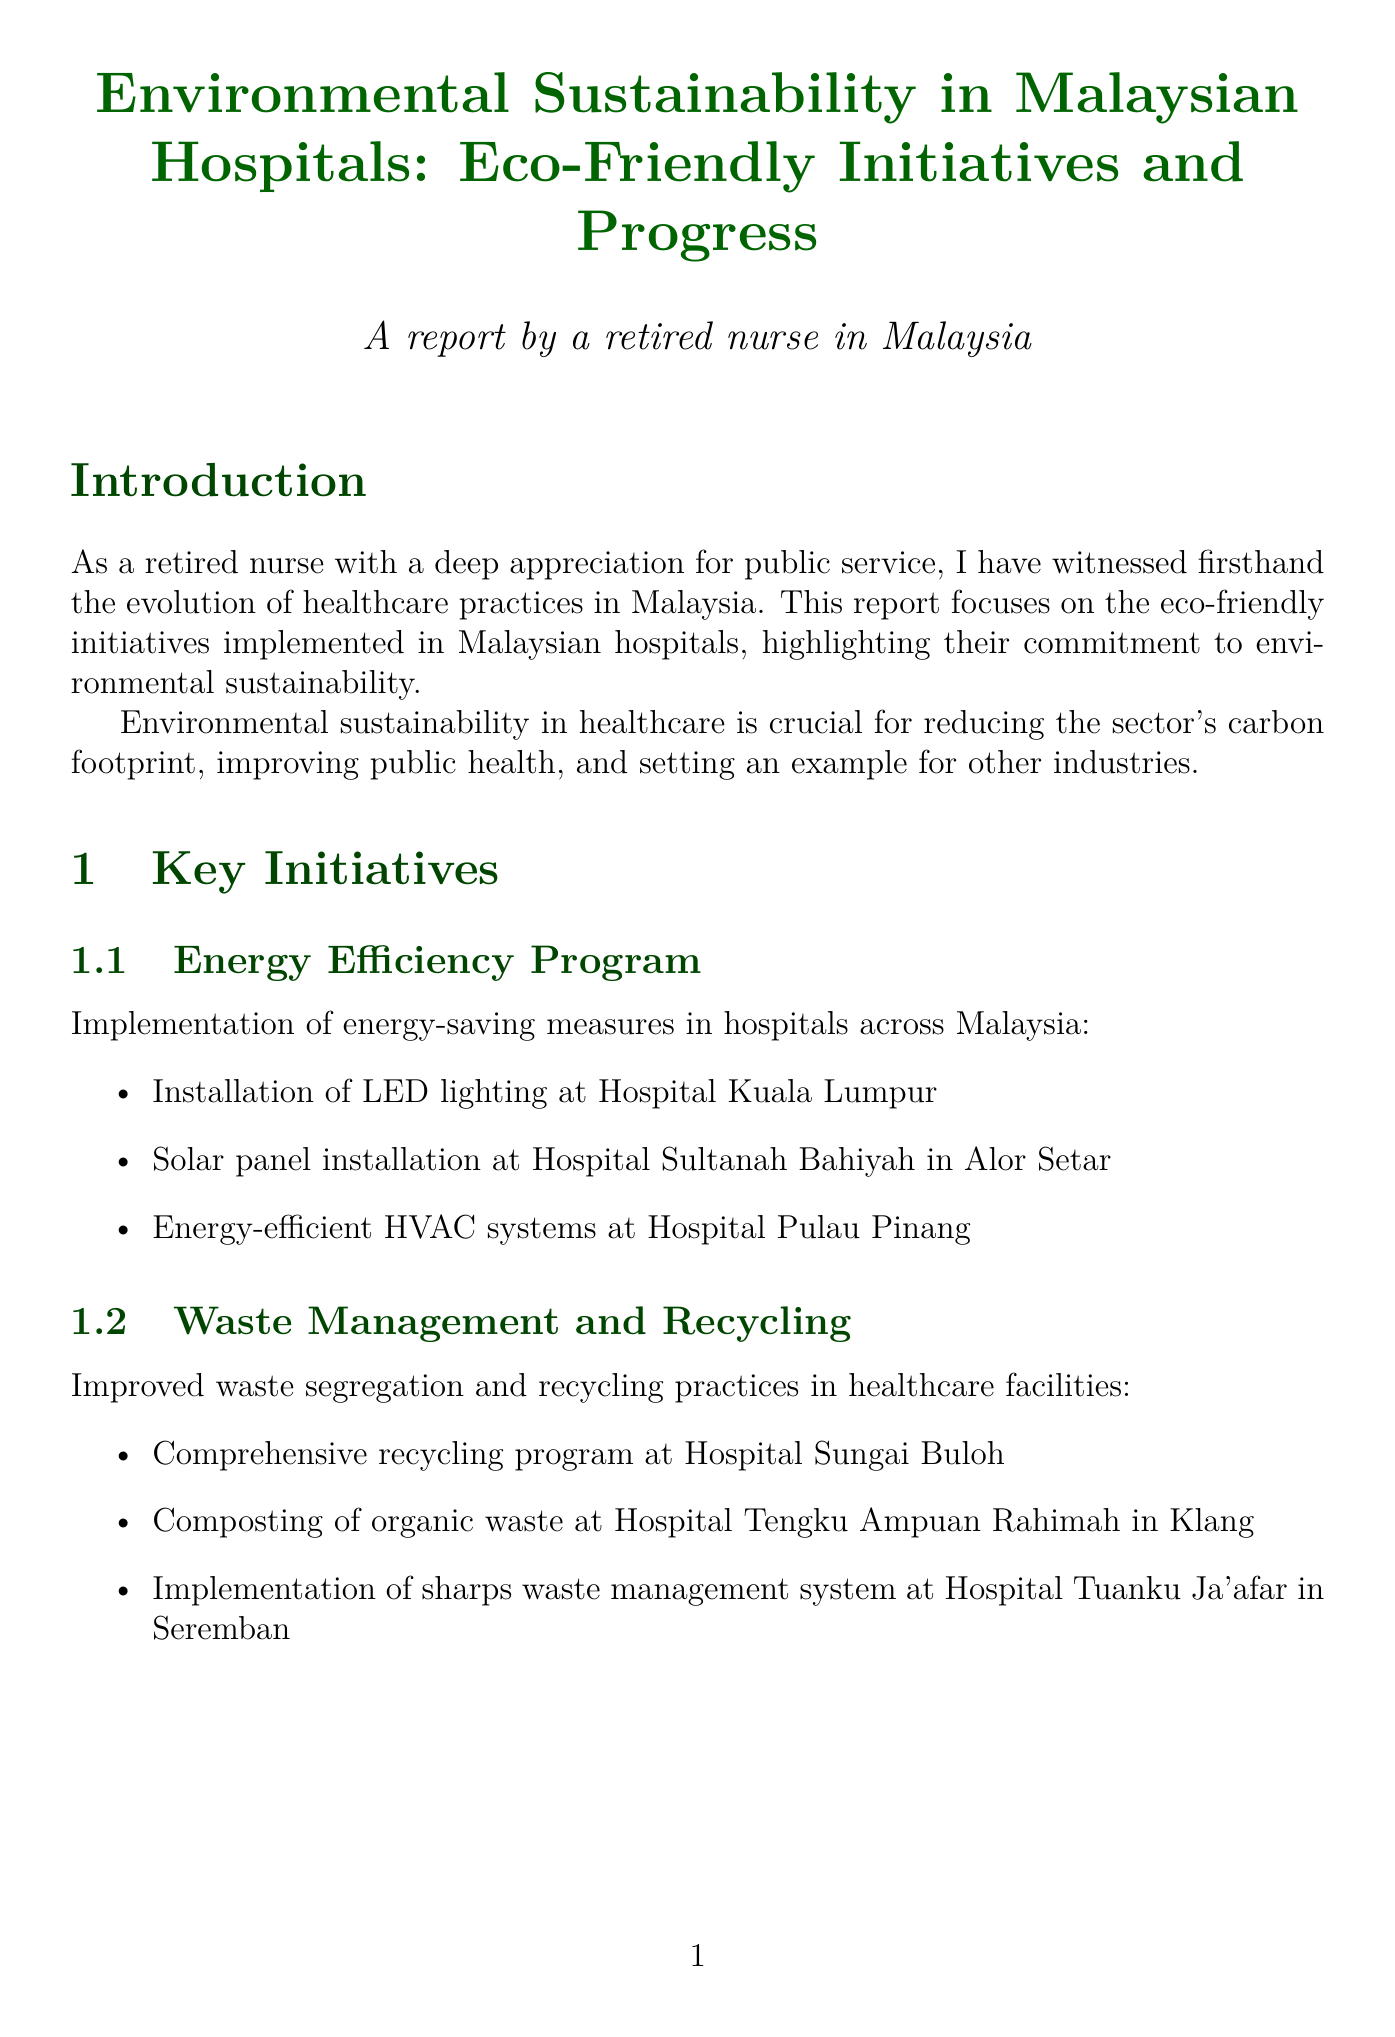What is the title of the report? The title of the report is mentioned at the beginning and is "Environmental Sustainability in Malaysian Hospitals: Eco-Friendly Initiatives and Progress."
Answer: Environmental Sustainability in Malaysian Hospitals: Eco-Friendly Initiatives and Progress What is one example of an energy efficiency initiative? The document lists specific examples of energy efficiency initiatives, one being the installation of LED lighting at Hospital Kuala Lumpur.
Answer: Installation of LED lighting at Hospital Kuala Lumpur How much has HUSM reduced its carbon emissions? The impact section for HUSM states that it has reduced its carbon emissions by 20%.
Answer: 20% What is a key challenge mentioned for sustainability initiatives? The report identifies limited funding for sustainability initiatives as one of the key challenges faced.
Answer: Limited funding Which hospital implemented a paperless medical records system? The case study for the National Heart Institute states that it has implemented paperless medical records.
Answer: National Heart Institute What is a recommendation for improving sustainability in healthcare? The document suggests increasing government funding for green healthcare initiatives as one of the recommendations.
Answer: Increase government funding for green healthcare initiatives By what percentage did the National Heart Institute reduce paper consumption? The impact section for the National Heart Institute states that it has reduced paper consumption by 70%.
Answer: 70% What program was implemented at Hospital Universiti Sains Malaysia? It mentions the implementation of a comprehensive Green Hospital program at HUSM.
Answer: Comprehensive Green Hospital program 